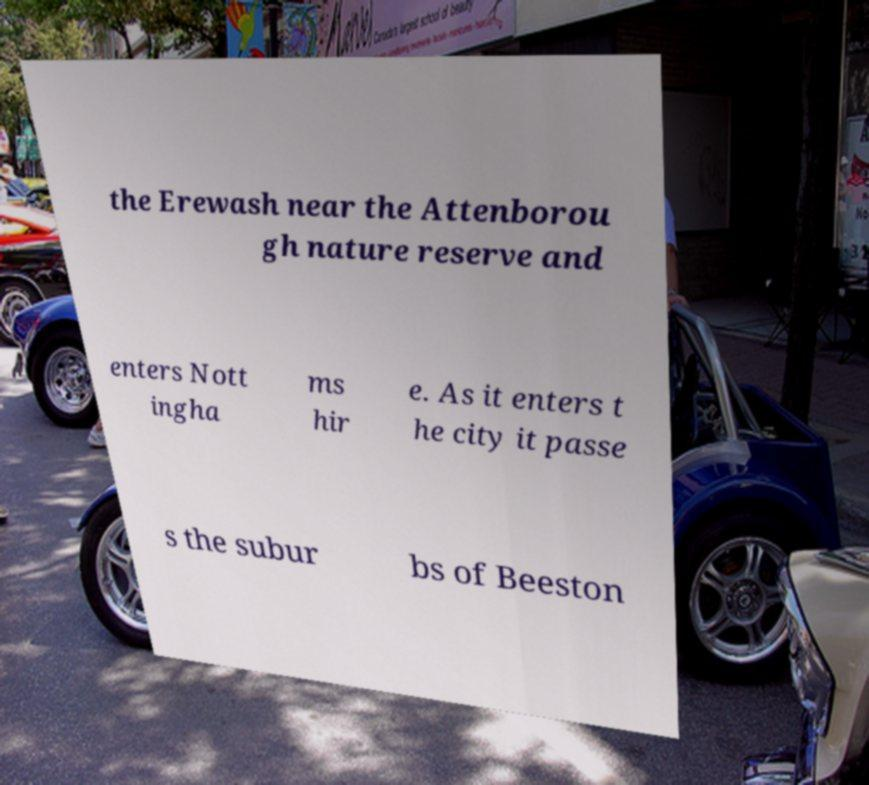There's text embedded in this image that I need extracted. Can you transcribe it verbatim? the Erewash near the Attenborou gh nature reserve and enters Nott ingha ms hir e. As it enters t he city it passe s the subur bs of Beeston 